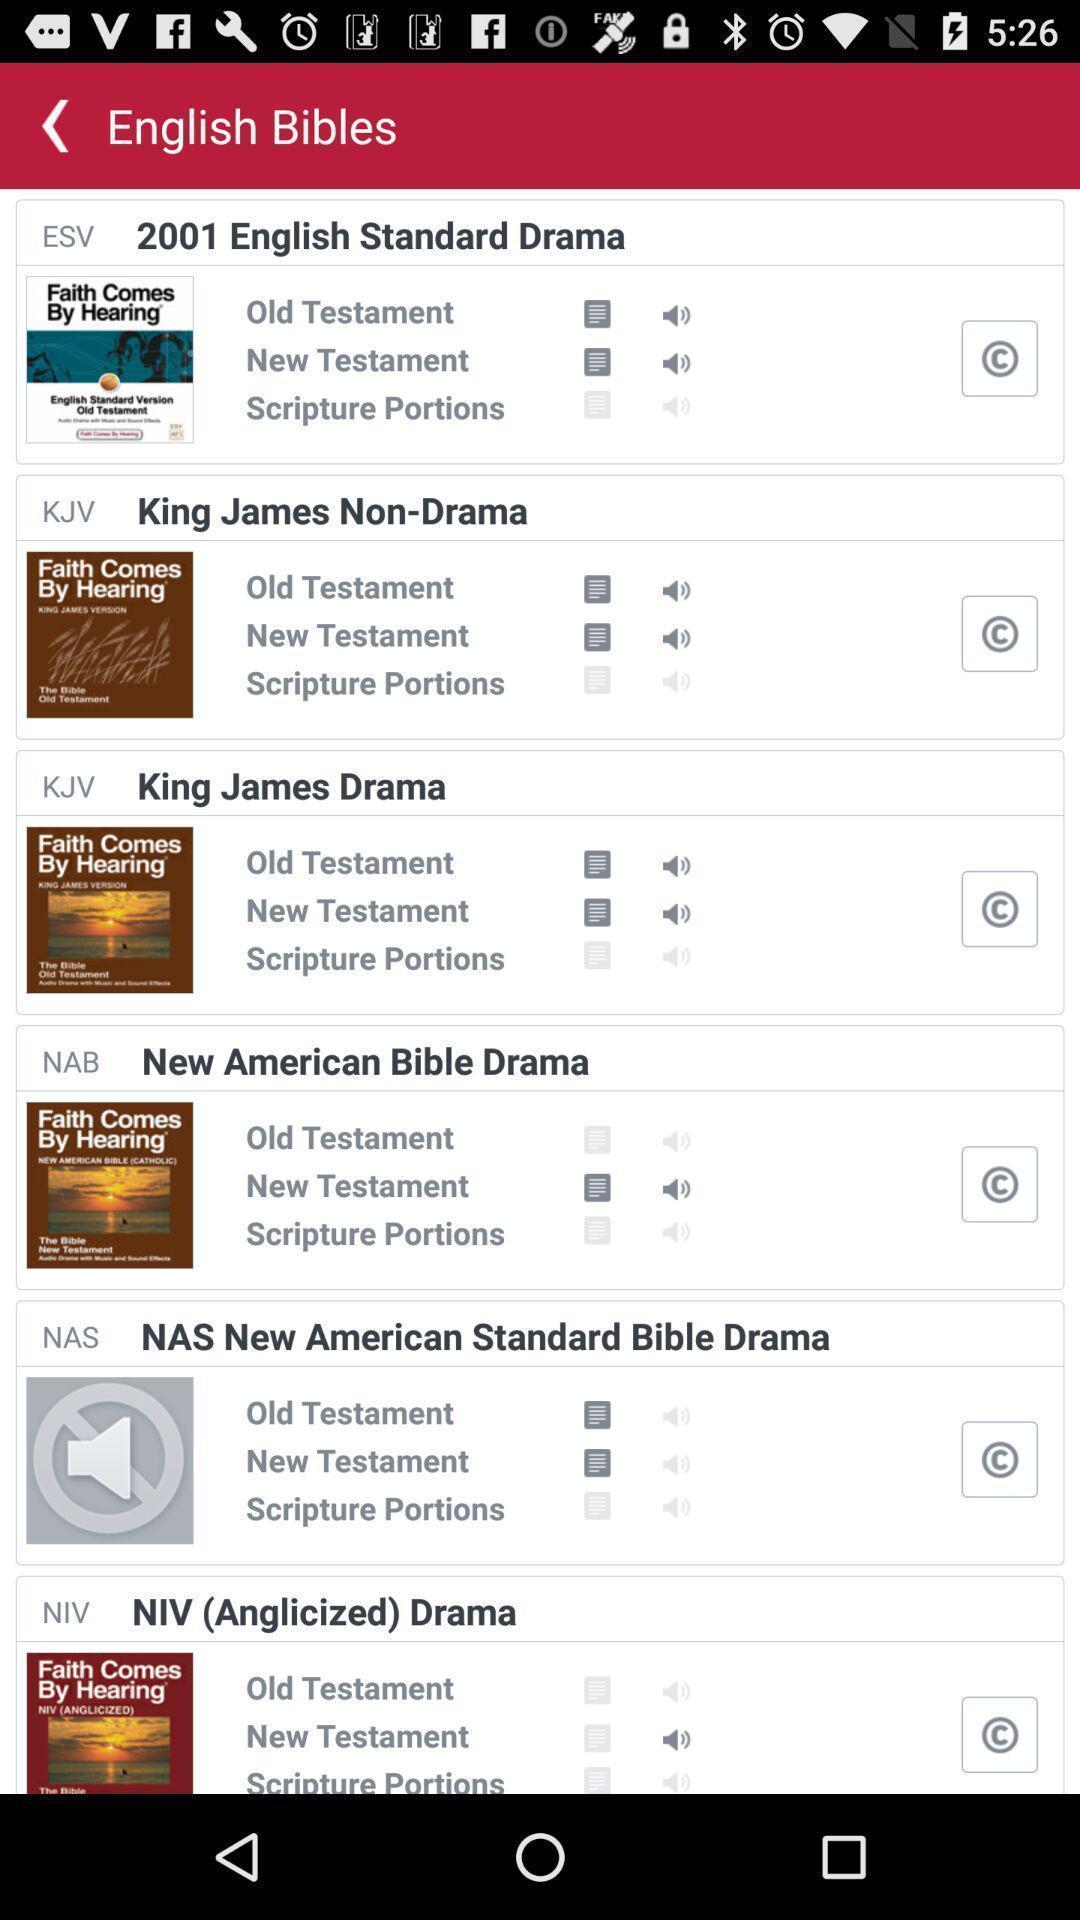Provide a detailed account of this screenshot. Screen shows english bibles. 